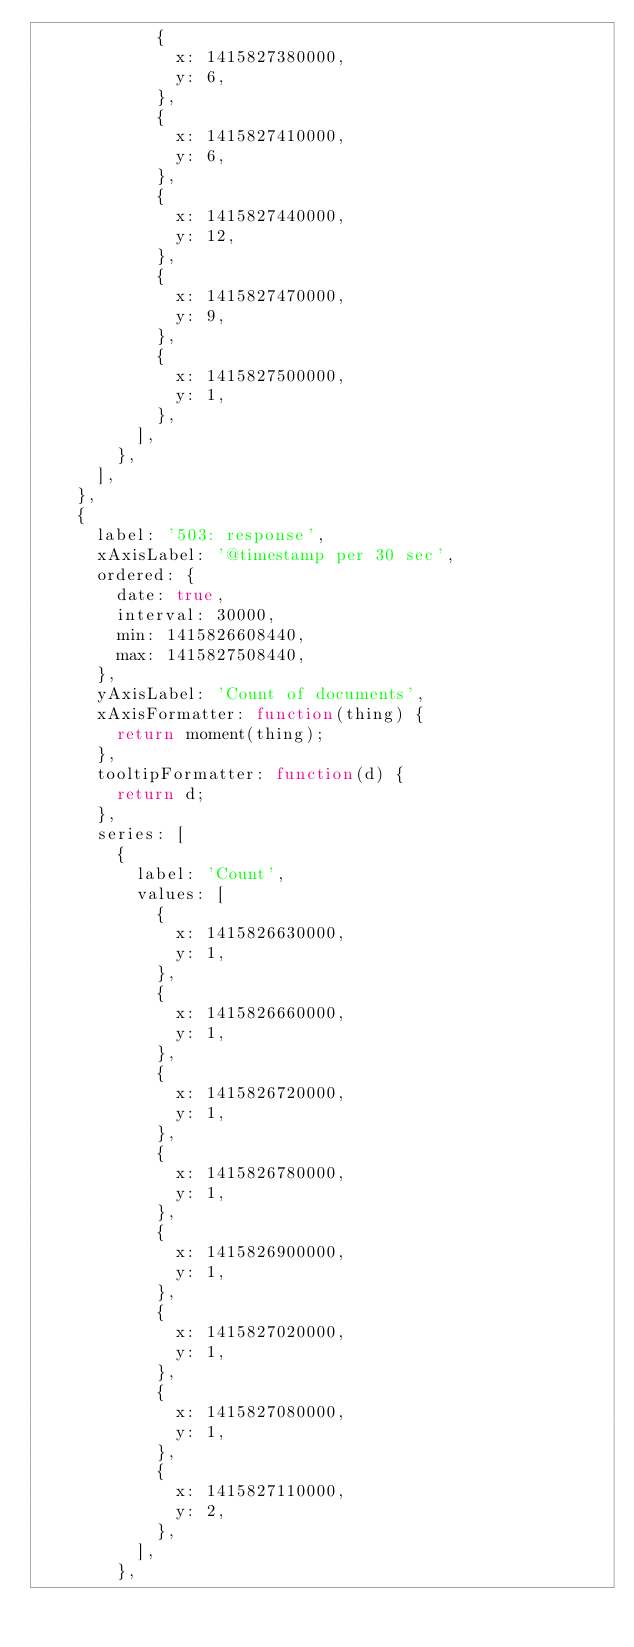<code> <loc_0><loc_0><loc_500><loc_500><_JavaScript_>            {
              x: 1415827380000,
              y: 6,
            },
            {
              x: 1415827410000,
              y: 6,
            },
            {
              x: 1415827440000,
              y: 12,
            },
            {
              x: 1415827470000,
              y: 9,
            },
            {
              x: 1415827500000,
              y: 1,
            },
          ],
        },
      ],
    },
    {
      label: '503: response',
      xAxisLabel: '@timestamp per 30 sec',
      ordered: {
        date: true,
        interval: 30000,
        min: 1415826608440,
        max: 1415827508440,
      },
      yAxisLabel: 'Count of documents',
      xAxisFormatter: function(thing) {
        return moment(thing);
      },
      tooltipFormatter: function(d) {
        return d;
      },
      series: [
        {
          label: 'Count',
          values: [
            {
              x: 1415826630000,
              y: 1,
            },
            {
              x: 1415826660000,
              y: 1,
            },
            {
              x: 1415826720000,
              y: 1,
            },
            {
              x: 1415826780000,
              y: 1,
            },
            {
              x: 1415826900000,
              y: 1,
            },
            {
              x: 1415827020000,
              y: 1,
            },
            {
              x: 1415827080000,
              y: 1,
            },
            {
              x: 1415827110000,
              y: 2,
            },
          ],
        },</code> 